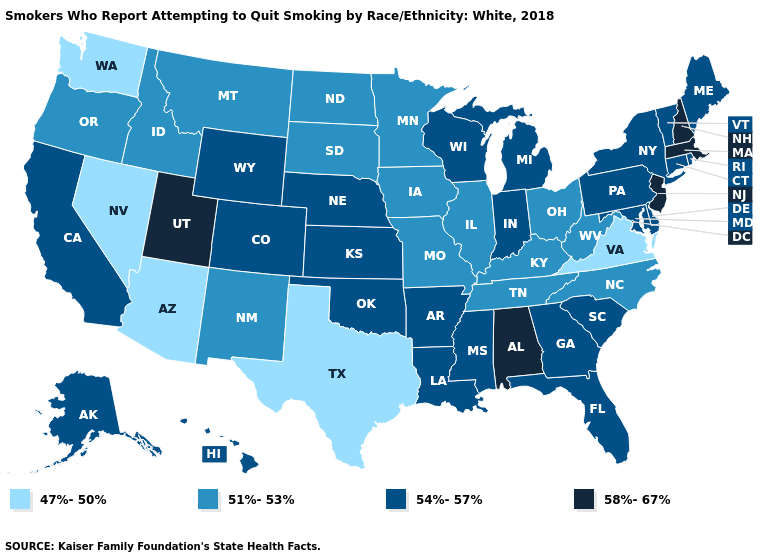What is the value of Ohio?
Concise answer only. 51%-53%. How many symbols are there in the legend?
Give a very brief answer. 4. What is the highest value in states that border Wyoming?
Quick response, please. 58%-67%. Does Indiana have the highest value in the MidWest?
Quick response, please. Yes. What is the lowest value in the MidWest?
Write a very short answer. 51%-53%. Name the states that have a value in the range 47%-50%?
Quick response, please. Arizona, Nevada, Texas, Virginia, Washington. Which states have the lowest value in the USA?
Short answer required. Arizona, Nevada, Texas, Virginia, Washington. What is the value of Nevada?
Short answer required. 47%-50%. What is the lowest value in the Northeast?
Give a very brief answer. 54%-57%. Is the legend a continuous bar?
Short answer required. No. What is the lowest value in the Northeast?
Answer briefly. 54%-57%. What is the lowest value in states that border Illinois?
Quick response, please. 51%-53%. Name the states that have a value in the range 47%-50%?
Concise answer only. Arizona, Nevada, Texas, Virginia, Washington. What is the value of North Dakota?
Be succinct. 51%-53%. Name the states that have a value in the range 51%-53%?
Give a very brief answer. Idaho, Illinois, Iowa, Kentucky, Minnesota, Missouri, Montana, New Mexico, North Carolina, North Dakota, Ohio, Oregon, South Dakota, Tennessee, West Virginia. 